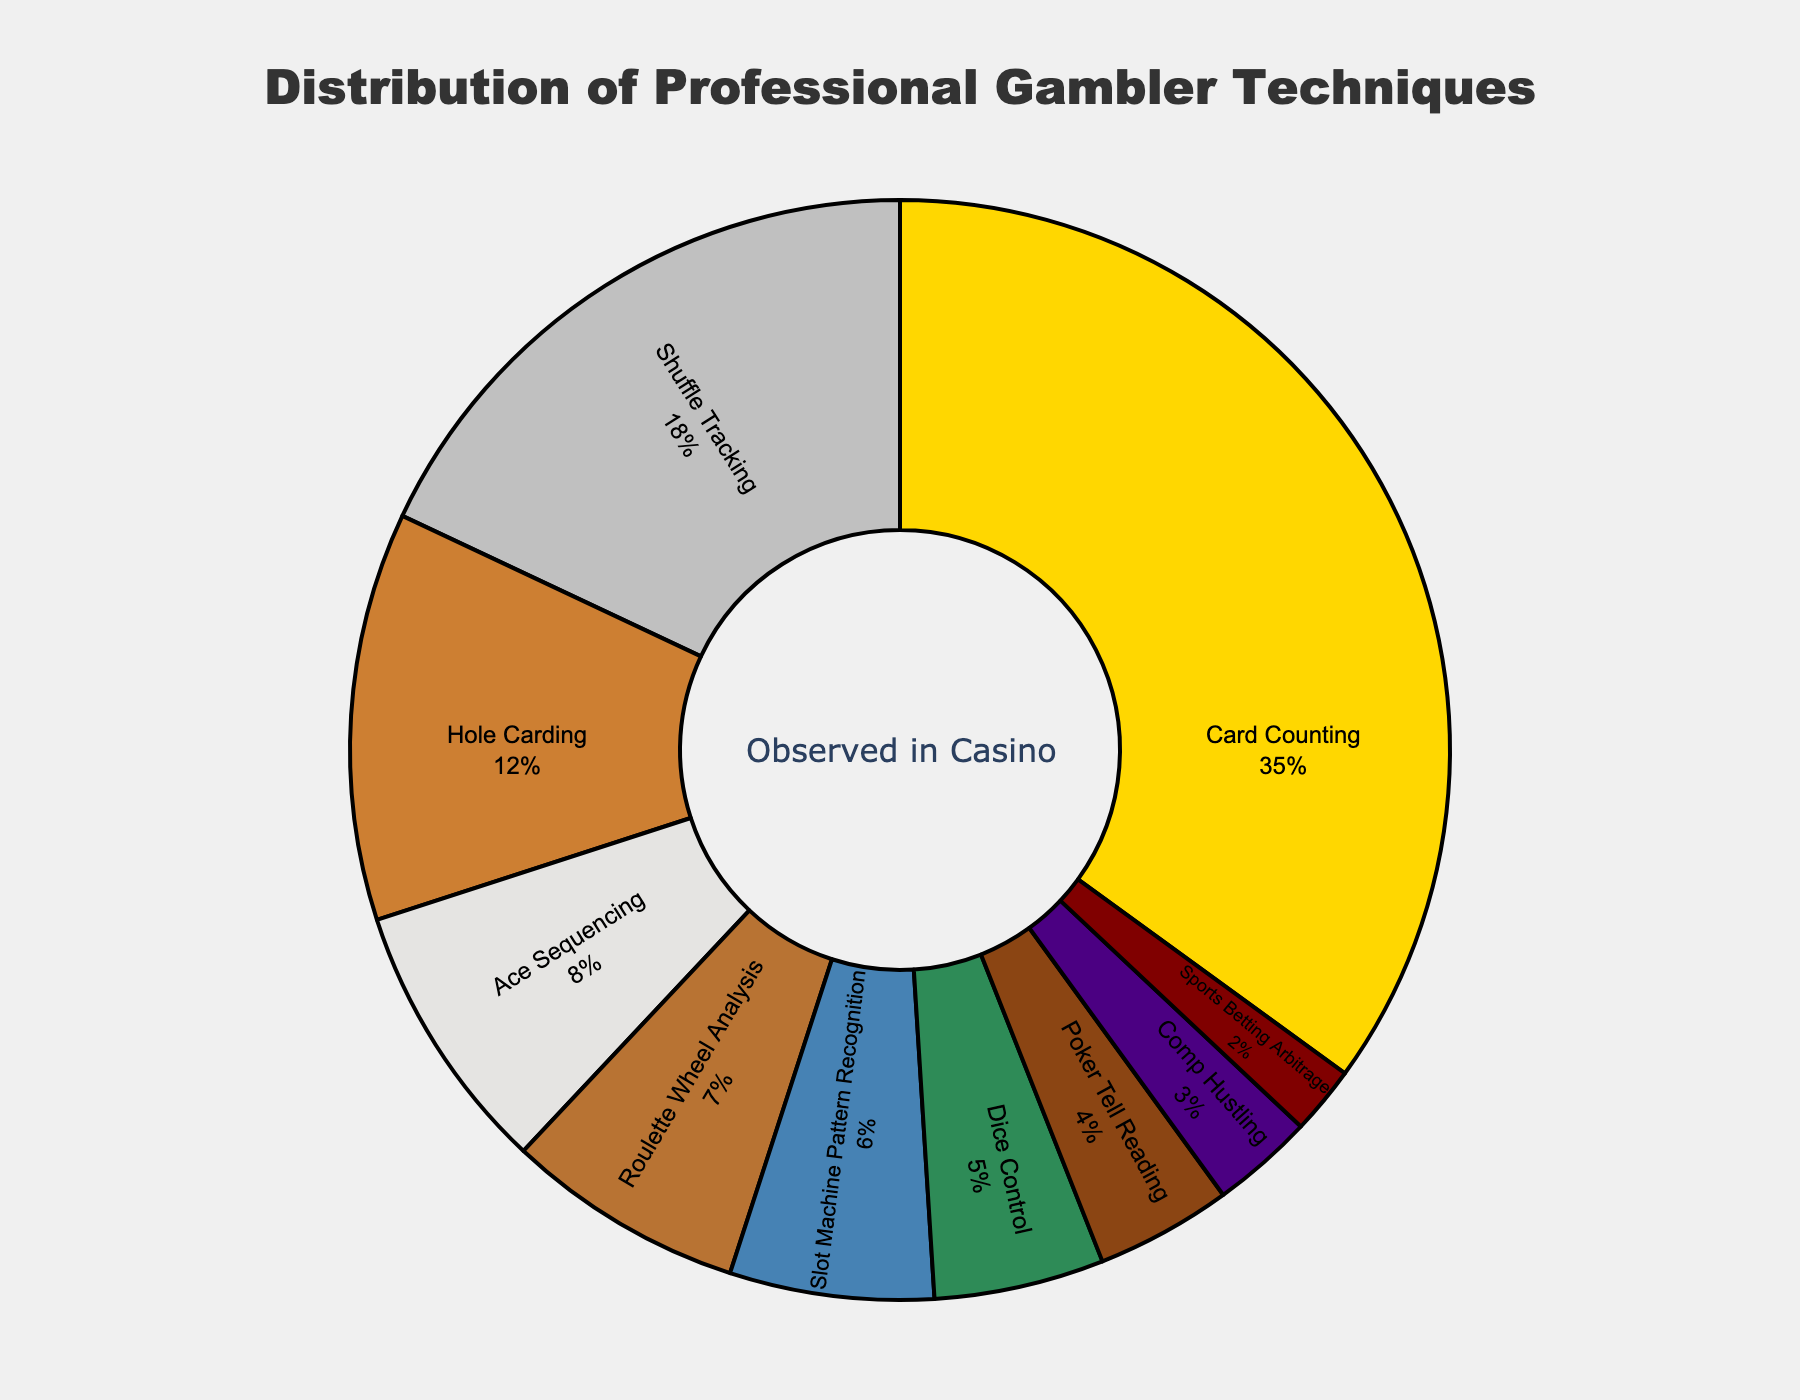Which technique is most prevalent among professional gamblers in the casino? The pie chart shows different techniques used by professional gamblers with their respective percentages. The technique with the highest percentage is the most prevalent.
Answer: Card Counting How much more prevalent is Card Counting compared to Shuffle Tracking? From the pie chart, Card Counting has a percentage of 35% while Shuffle Tracking has 18%. The difference can be calculated by subtracting the percentage of Shuffle Tracking from the percentage of Card Counting.
Answer: 17% What is the combined percentage of Shuffle Tracking and Hole Carding techniques? According to the pie chart, Shuffle Tracking is 18% and Hole Carding is 12%. Adding these percentages gives the combined total.
Answer: 30% Which technique has the smallest representation in the casino? The pie chart indicates the percentage share of each technique. The one with the smallest percentage is the least represented.
Answer: Sports Betting Arbitrage Are the combined percentages of Dice Control and Slot Machine Pattern Recognition greater or less than the percentage of Card Counting? Dice Control is 5% and Slot Machine Pattern Recognition is 6%. Their combined percentage is 5% + 6% = 11%. Comparing this to Card Counting, which is 35%, we see if the combined total is greater or less.
Answer: Less Which techniques together make up less than 10% of the total? Reviewing the pie chart, techniques with individual percentages summing to less than 10% are identified.
Answer: Poker Tell Reading, Comp Hustling, Sports Betting Arbitrage How many techniques account for more than 10% each? From the pie chart, count the number of techniques with percentages above 10%.
Answer: 3 Is the prevalence of Ace Sequencing greater than or equal to that of Roulette Wheel Analysis? The percentages for Ace Sequencing and Roulette Wheel Analysis are compared. Ace Sequencing has 8% and Roulette Wheel Analysis has 7%.
Answer: Greater What is the percentage difference between the least and most prevalent techniques? The least prevalent technique is Sports Betting Arbitrage at 2% and the most prevalent is Card Counting at 35%. The percentage difference is calculated by subtracting the percentage of the least prevalent technique from the most prevalent one.
Answer: 33% Which technique shares the same color as Slot Machine Pattern Recognition on the pie chart? Slot Machine Pattern Recognition is marked with a specific color in the pie chart. Identify the technique labeled with the same color.
Answer: N/A (this requires visual identification beyond the provided data) 